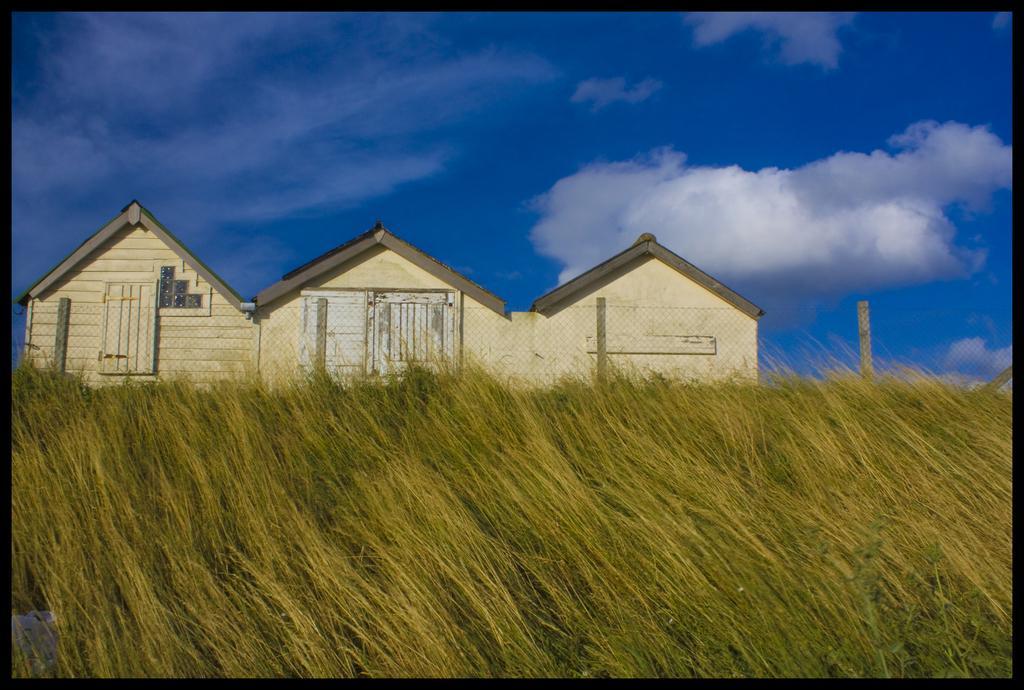Please provide a concise description of this image. In this image we can see some houses with roof. We can also see some wooden poles, a metal fence and the sky which looks cloudy. 